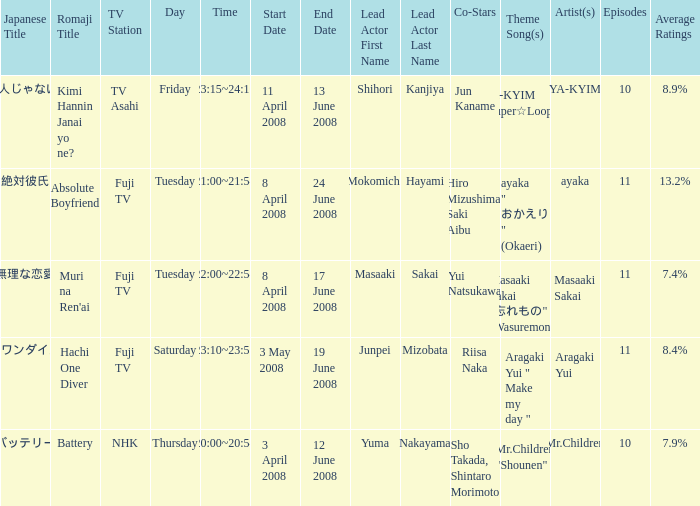Who were the starting actors in the time frame of  tuesday 22:00~22:54 8 april 2008 to 17 june 2008? Masaaki Sakai , Yui Natsukawa. Give me the full table as a dictionary. {'header': ['Japanese Title', 'Romaji Title', 'TV Station', 'Day', 'Time', 'Start Date', 'End Date', 'Lead Actor First Name', 'Lead Actor Last Name', 'Co-Stars', 'Theme Song(s)', 'Artist(s)', 'Episodes', 'Average Ratings'], 'rows': [['キミ犯人じゃないよね?', 'Kimi Hannin Janai yo ne?', 'TV Asahi', 'Friday', '23:15~24:10', '11 April 2008', '13 June 2008', 'Shihori', 'Kanjiya', 'Jun Kaname', 'YA-KYIM "Super☆Looper"', 'YA-KYIM', '10', '8.9%'], ['絶対彼氏', 'Absolute Boyfriend', 'Fuji TV', 'Tuesday', '21:00~21:54', '8 April 2008', '24 June 2008', 'Mokomichi', 'Hayami', 'Hiro Mizushima, Saki Aibu', 'ayaka " おかえり " (Okaeri)', 'ayaka', '11', '13.2%'], ['無理な恋愛', "Muri na Ren'ai", 'Fuji TV', 'Tuesday', '22:00~22:54', '8 April 2008', '17 June 2008', 'Masaaki', 'Sakai', 'Yui Natsukawa', 'Masaaki Sakai "忘れもの" (Wasuremono)', 'Masaaki Sakai', '11', '7.4%'], ['ハチワンダイバー', 'Hachi One Diver', 'Fuji TV', 'Saturday', '23:10~23:55', '3 May 2008', '19 June 2008', 'Junpei', 'Mizobata', 'Riisa Naka', 'Aragaki Yui " Make my day "', 'Aragaki Yui', '11', '8.4%'], ['バッテリー', 'Battery', 'NHK', 'Thursday', '20:00~20:54', '3 April 2008', '12 June 2008', 'Yuma', 'Nakayama', 'Sho Takada, Shintaro Morimoto', 'Mr.Children "Shounen"', 'Mr.Children', '10', '7.9%']]} 